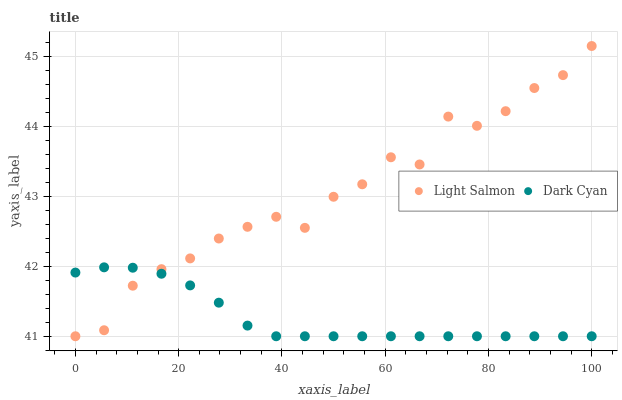Does Dark Cyan have the minimum area under the curve?
Answer yes or no. Yes. Does Light Salmon have the maximum area under the curve?
Answer yes or no. Yes. Does Light Salmon have the minimum area under the curve?
Answer yes or no. No. Is Dark Cyan the smoothest?
Answer yes or no. Yes. Is Light Salmon the roughest?
Answer yes or no. Yes. Is Light Salmon the smoothest?
Answer yes or no. No. Does Dark Cyan have the lowest value?
Answer yes or no. Yes. Does Light Salmon have the highest value?
Answer yes or no. Yes. Does Light Salmon intersect Dark Cyan?
Answer yes or no. Yes. Is Light Salmon less than Dark Cyan?
Answer yes or no. No. Is Light Salmon greater than Dark Cyan?
Answer yes or no. No. 